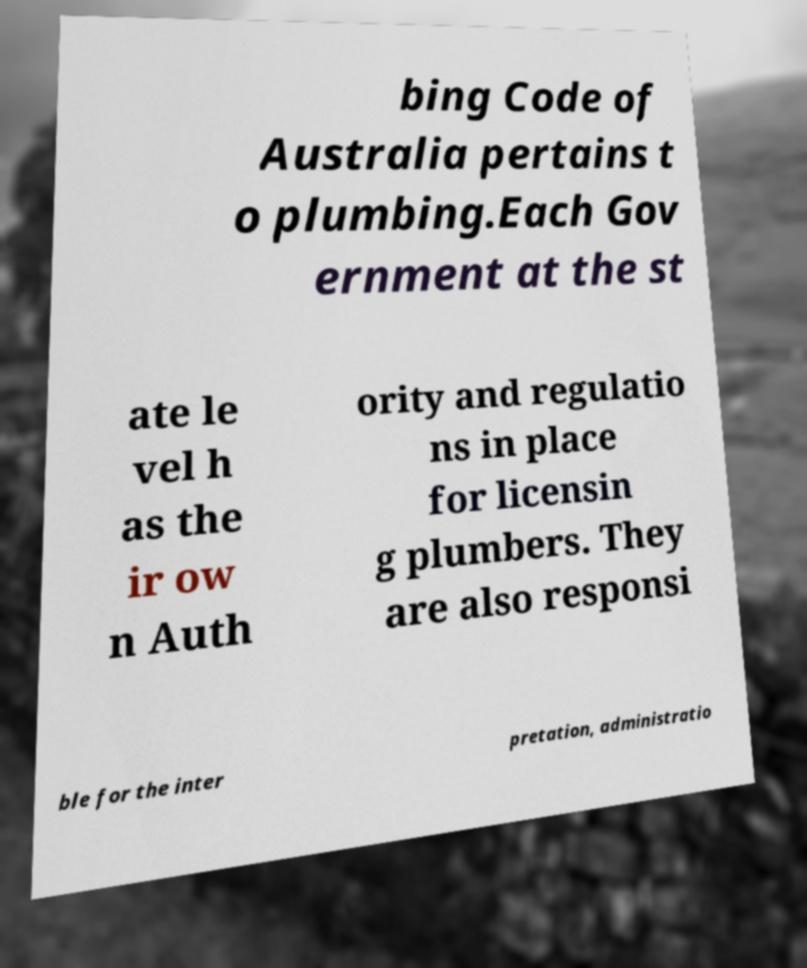I need the written content from this picture converted into text. Can you do that? bing Code of Australia pertains t o plumbing.Each Gov ernment at the st ate le vel h as the ir ow n Auth ority and regulatio ns in place for licensin g plumbers. They are also responsi ble for the inter pretation, administratio 